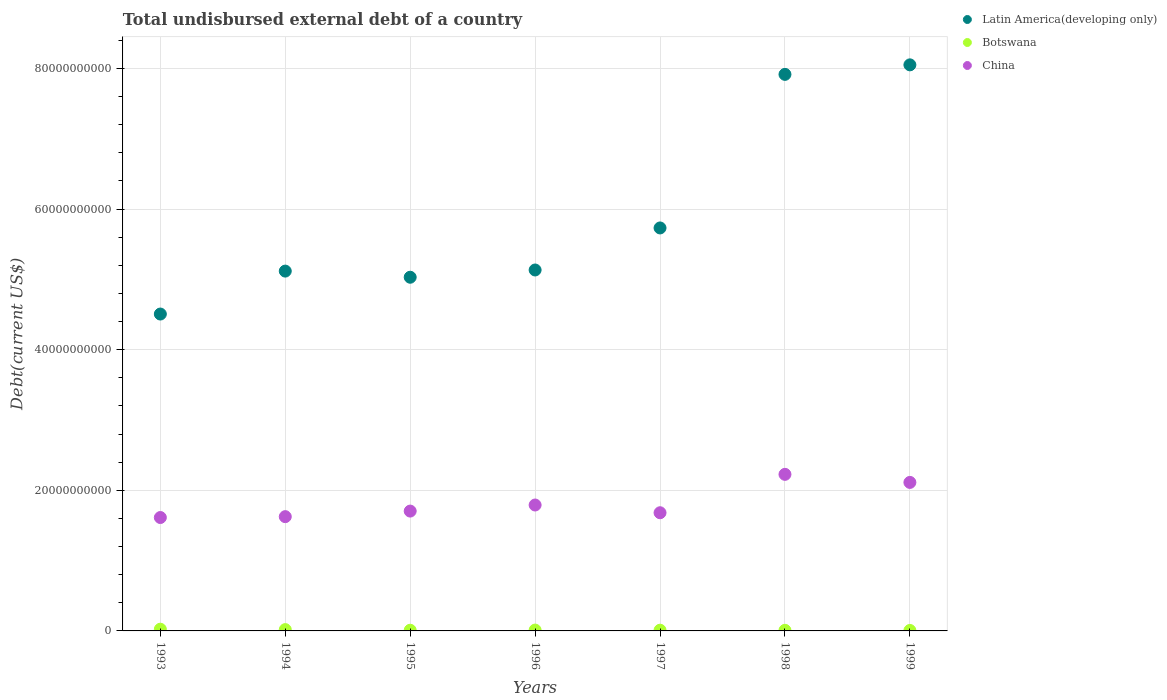How many different coloured dotlines are there?
Ensure brevity in your answer.  3. What is the total undisbursed external debt in Botswana in 1999?
Provide a short and direct response. 6.58e+07. Across all years, what is the maximum total undisbursed external debt in Botswana?
Provide a succinct answer. 2.44e+08. Across all years, what is the minimum total undisbursed external debt in China?
Offer a terse response. 1.61e+1. In which year was the total undisbursed external debt in China minimum?
Give a very brief answer. 1993. What is the total total undisbursed external debt in Latin America(developing only) in the graph?
Offer a terse response. 4.15e+11. What is the difference between the total undisbursed external debt in Botswana in 1995 and that in 1998?
Keep it short and to the point. 1.10e+07. What is the difference between the total undisbursed external debt in Botswana in 1999 and the total undisbursed external debt in Latin America(developing only) in 1996?
Offer a very short reply. -5.13e+1. What is the average total undisbursed external debt in China per year?
Give a very brief answer. 1.82e+1. In the year 1995, what is the difference between the total undisbursed external debt in China and total undisbursed external debt in Botswana?
Offer a very short reply. 1.69e+1. What is the ratio of the total undisbursed external debt in China in 1997 to that in 1998?
Your response must be concise. 0.75. Is the difference between the total undisbursed external debt in China in 1996 and 1997 greater than the difference between the total undisbursed external debt in Botswana in 1996 and 1997?
Offer a very short reply. Yes. What is the difference between the highest and the second highest total undisbursed external debt in China?
Provide a succinct answer. 1.15e+09. What is the difference between the highest and the lowest total undisbursed external debt in Latin America(developing only)?
Make the answer very short. 3.54e+1. Is the sum of the total undisbursed external debt in China in 1996 and 1998 greater than the maximum total undisbursed external debt in Botswana across all years?
Your answer should be very brief. Yes. Is it the case that in every year, the sum of the total undisbursed external debt in China and total undisbursed external debt in Latin America(developing only)  is greater than the total undisbursed external debt in Botswana?
Provide a succinct answer. Yes. Does the total undisbursed external debt in Latin America(developing only) monotonically increase over the years?
Your response must be concise. No. Is the total undisbursed external debt in Latin America(developing only) strictly less than the total undisbursed external debt in Botswana over the years?
Offer a very short reply. No. How many years are there in the graph?
Keep it short and to the point. 7. Are the values on the major ticks of Y-axis written in scientific E-notation?
Offer a terse response. No. Where does the legend appear in the graph?
Make the answer very short. Top right. How are the legend labels stacked?
Your answer should be compact. Vertical. What is the title of the graph?
Offer a terse response. Total undisbursed external debt of a country. What is the label or title of the X-axis?
Offer a terse response. Years. What is the label or title of the Y-axis?
Provide a short and direct response. Debt(current US$). What is the Debt(current US$) in Latin America(developing only) in 1993?
Keep it short and to the point. 4.51e+1. What is the Debt(current US$) of Botswana in 1993?
Your answer should be compact. 2.44e+08. What is the Debt(current US$) in China in 1993?
Your answer should be compact. 1.61e+1. What is the Debt(current US$) of Latin America(developing only) in 1994?
Make the answer very short. 5.12e+1. What is the Debt(current US$) of Botswana in 1994?
Offer a very short reply. 1.87e+08. What is the Debt(current US$) of China in 1994?
Ensure brevity in your answer.  1.63e+1. What is the Debt(current US$) of Latin America(developing only) in 1995?
Offer a very short reply. 5.03e+1. What is the Debt(current US$) in Botswana in 1995?
Keep it short and to the point. 9.74e+07. What is the Debt(current US$) in China in 1995?
Provide a short and direct response. 1.70e+1. What is the Debt(current US$) in Latin America(developing only) in 1996?
Offer a terse response. 5.13e+1. What is the Debt(current US$) of Botswana in 1996?
Offer a terse response. 1.20e+08. What is the Debt(current US$) in China in 1996?
Give a very brief answer. 1.79e+1. What is the Debt(current US$) in Latin America(developing only) in 1997?
Provide a succinct answer. 5.73e+1. What is the Debt(current US$) in Botswana in 1997?
Ensure brevity in your answer.  1.03e+08. What is the Debt(current US$) of China in 1997?
Your response must be concise. 1.68e+1. What is the Debt(current US$) of Latin America(developing only) in 1998?
Make the answer very short. 7.91e+1. What is the Debt(current US$) in Botswana in 1998?
Provide a succinct answer. 8.64e+07. What is the Debt(current US$) of China in 1998?
Your answer should be compact. 2.23e+1. What is the Debt(current US$) of Latin America(developing only) in 1999?
Give a very brief answer. 8.05e+1. What is the Debt(current US$) of Botswana in 1999?
Provide a succinct answer. 6.58e+07. What is the Debt(current US$) in China in 1999?
Keep it short and to the point. 2.11e+1. Across all years, what is the maximum Debt(current US$) in Latin America(developing only)?
Keep it short and to the point. 8.05e+1. Across all years, what is the maximum Debt(current US$) in Botswana?
Offer a very short reply. 2.44e+08. Across all years, what is the maximum Debt(current US$) of China?
Offer a very short reply. 2.23e+1. Across all years, what is the minimum Debt(current US$) of Latin America(developing only)?
Your response must be concise. 4.51e+1. Across all years, what is the minimum Debt(current US$) in Botswana?
Provide a succinct answer. 6.58e+07. Across all years, what is the minimum Debt(current US$) of China?
Give a very brief answer. 1.61e+1. What is the total Debt(current US$) in Latin America(developing only) in the graph?
Provide a short and direct response. 4.15e+11. What is the total Debt(current US$) in Botswana in the graph?
Provide a succinct answer. 9.03e+08. What is the total Debt(current US$) of China in the graph?
Your answer should be compact. 1.28e+11. What is the difference between the Debt(current US$) of Latin America(developing only) in 1993 and that in 1994?
Ensure brevity in your answer.  -6.11e+09. What is the difference between the Debt(current US$) of Botswana in 1993 and that in 1994?
Make the answer very short. 5.70e+07. What is the difference between the Debt(current US$) of China in 1993 and that in 1994?
Your response must be concise. -1.24e+08. What is the difference between the Debt(current US$) of Latin America(developing only) in 1993 and that in 1995?
Offer a very short reply. -5.23e+09. What is the difference between the Debt(current US$) of Botswana in 1993 and that in 1995?
Keep it short and to the point. 1.46e+08. What is the difference between the Debt(current US$) of China in 1993 and that in 1995?
Give a very brief answer. -9.15e+08. What is the difference between the Debt(current US$) in Latin America(developing only) in 1993 and that in 1996?
Provide a succinct answer. -6.27e+09. What is the difference between the Debt(current US$) of Botswana in 1993 and that in 1996?
Give a very brief answer. 1.23e+08. What is the difference between the Debt(current US$) in China in 1993 and that in 1996?
Your answer should be very brief. -1.78e+09. What is the difference between the Debt(current US$) in Latin America(developing only) in 1993 and that in 1997?
Offer a terse response. -1.22e+1. What is the difference between the Debt(current US$) in Botswana in 1993 and that in 1997?
Ensure brevity in your answer.  1.40e+08. What is the difference between the Debt(current US$) of China in 1993 and that in 1997?
Make the answer very short. -6.80e+08. What is the difference between the Debt(current US$) in Latin America(developing only) in 1993 and that in 1998?
Provide a short and direct response. -3.41e+1. What is the difference between the Debt(current US$) in Botswana in 1993 and that in 1998?
Make the answer very short. 1.57e+08. What is the difference between the Debt(current US$) of China in 1993 and that in 1998?
Offer a terse response. -6.14e+09. What is the difference between the Debt(current US$) in Latin America(developing only) in 1993 and that in 1999?
Your answer should be compact. -3.54e+1. What is the difference between the Debt(current US$) of Botswana in 1993 and that in 1999?
Offer a terse response. 1.78e+08. What is the difference between the Debt(current US$) in China in 1993 and that in 1999?
Your response must be concise. -4.99e+09. What is the difference between the Debt(current US$) in Latin America(developing only) in 1994 and that in 1995?
Your response must be concise. 8.73e+08. What is the difference between the Debt(current US$) in Botswana in 1994 and that in 1995?
Your answer should be compact. 8.92e+07. What is the difference between the Debt(current US$) in China in 1994 and that in 1995?
Offer a terse response. -7.91e+08. What is the difference between the Debt(current US$) in Latin America(developing only) in 1994 and that in 1996?
Offer a very short reply. -1.58e+08. What is the difference between the Debt(current US$) of Botswana in 1994 and that in 1996?
Provide a succinct answer. 6.63e+07. What is the difference between the Debt(current US$) in China in 1994 and that in 1996?
Offer a very short reply. -1.66e+09. What is the difference between the Debt(current US$) in Latin America(developing only) in 1994 and that in 1997?
Provide a short and direct response. -6.14e+09. What is the difference between the Debt(current US$) in Botswana in 1994 and that in 1997?
Give a very brief answer. 8.31e+07. What is the difference between the Debt(current US$) in China in 1994 and that in 1997?
Make the answer very short. -5.56e+08. What is the difference between the Debt(current US$) in Latin America(developing only) in 1994 and that in 1998?
Offer a terse response. -2.80e+1. What is the difference between the Debt(current US$) in Botswana in 1994 and that in 1998?
Give a very brief answer. 1.00e+08. What is the difference between the Debt(current US$) of China in 1994 and that in 1998?
Your answer should be compact. -6.02e+09. What is the difference between the Debt(current US$) of Latin America(developing only) in 1994 and that in 1999?
Your answer should be compact. -2.93e+1. What is the difference between the Debt(current US$) of Botswana in 1994 and that in 1999?
Provide a succinct answer. 1.21e+08. What is the difference between the Debt(current US$) of China in 1994 and that in 1999?
Provide a short and direct response. -4.87e+09. What is the difference between the Debt(current US$) of Latin America(developing only) in 1995 and that in 1996?
Keep it short and to the point. -1.03e+09. What is the difference between the Debt(current US$) in Botswana in 1995 and that in 1996?
Offer a very short reply. -2.28e+07. What is the difference between the Debt(current US$) in China in 1995 and that in 1996?
Keep it short and to the point. -8.65e+08. What is the difference between the Debt(current US$) in Latin America(developing only) in 1995 and that in 1997?
Your answer should be very brief. -7.01e+09. What is the difference between the Debt(current US$) in Botswana in 1995 and that in 1997?
Your response must be concise. -6.05e+06. What is the difference between the Debt(current US$) in China in 1995 and that in 1997?
Make the answer very short. 2.35e+08. What is the difference between the Debt(current US$) of Latin America(developing only) in 1995 and that in 1998?
Your response must be concise. -2.88e+1. What is the difference between the Debt(current US$) in Botswana in 1995 and that in 1998?
Keep it short and to the point. 1.10e+07. What is the difference between the Debt(current US$) in China in 1995 and that in 1998?
Ensure brevity in your answer.  -5.22e+09. What is the difference between the Debt(current US$) in Latin America(developing only) in 1995 and that in 1999?
Offer a terse response. -3.02e+1. What is the difference between the Debt(current US$) in Botswana in 1995 and that in 1999?
Ensure brevity in your answer.  3.16e+07. What is the difference between the Debt(current US$) in China in 1995 and that in 1999?
Offer a terse response. -4.08e+09. What is the difference between the Debt(current US$) in Latin America(developing only) in 1996 and that in 1997?
Ensure brevity in your answer.  -5.98e+09. What is the difference between the Debt(current US$) in Botswana in 1996 and that in 1997?
Provide a short and direct response. 1.68e+07. What is the difference between the Debt(current US$) in China in 1996 and that in 1997?
Offer a terse response. 1.10e+09. What is the difference between the Debt(current US$) in Latin America(developing only) in 1996 and that in 1998?
Offer a terse response. -2.78e+1. What is the difference between the Debt(current US$) in Botswana in 1996 and that in 1998?
Provide a succinct answer. 3.39e+07. What is the difference between the Debt(current US$) in China in 1996 and that in 1998?
Provide a succinct answer. -4.36e+09. What is the difference between the Debt(current US$) of Latin America(developing only) in 1996 and that in 1999?
Your answer should be compact. -2.92e+1. What is the difference between the Debt(current US$) in Botswana in 1996 and that in 1999?
Provide a succinct answer. 5.45e+07. What is the difference between the Debt(current US$) of China in 1996 and that in 1999?
Make the answer very short. -3.21e+09. What is the difference between the Debt(current US$) of Latin America(developing only) in 1997 and that in 1998?
Your answer should be very brief. -2.18e+1. What is the difference between the Debt(current US$) in Botswana in 1997 and that in 1998?
Make the answer very short. 1.71e+07. What is the difference between the Debt(current US$) of China in 1997 and that in 1998?
Provide a succinct answer. -5.46e+09. What is the difference between the Debt(current US$) of Latin America(developing only) in 1997 and that in 1999?
Give a very brief answer. -2.32e+1. What is the difference between the Debt(current US$) of Botswana in 1997 and that in 1999?
Make the answer very short. 3.77e+07. What is the difference between the Debt(current US$) of China in 1997 and that in 1999?
Keep it short and to the point. -4.31e+09. What is the difference between the Debt(current US$) of Latin America(developing only) in 1998 and that in 1999?
Your answer should be compact. -1.35e+09. What is the difference between the Debt(current US$) of Botswana in 1998 and that in 1999?
Offer a very short reply. 2.06e+07. What is the difference between the Debt(current US$) in China in 1998 and that in 1999?
Give a very brief answer. 1.15e+09. What is the difference between the Debt(current US$) in Latin America(developing only) in 1993 and the Debt(current US$) in Botswana in 1994?
Give a very brief answer. 4.49e+1. What is the difference between the Debt(current US$) in Latin America(developing only) in 1993 and the Debt(current US$) in China in 1994?
Provide a succinct answer. 2.88e+1. What is the difference between the Debt(current US$) in Botswana in 1993 and the Debt(current US$) in China in 1994?
Keep it short and to the point. -1.60e+1. What is the difference between the Debt(current US$) of Latin America(developing only) in 1993 and the Debt(current US$) of Botswana in 1995?
Your response must be concise. 4.50e+1. What is the difference between the Debt(current US$) of Latin America(developing only) in 1993 and the Debt(current US$) of China in 1995?
Offer a terse response. 2.80e+1. What is the difference between the Debt(current US$) in Botswana in 1993 and the Debt(current US$) in China in 1995?
Your response must be concise. -1.68e+1. What is the difference between the Debt(current US$) of Latin America(developing only) in 1993 and the Debt(current US$) of Botswana in 1996?
Keep it short and to the point. 4.49e+1. What is the difference between the Debt(current US$) in Latin America(developing only) in 1993 and the Debt(current US$) in China in 1996?
Your answer should be very brief. 2.72e+1. What is the difference between the Debt(current US$) of Botswana in 1993 and the Debt(current US$) of China in 1996?
Offer a terse response. -1.77e+1. What is the difference between the Debt(current US$) of Latin America(developing only) in 1993 and the Debt(current US$) of Botswana in 1997?
Provide a short and direct response. 4.50e+1. What is the difference between the Debt(current US$) in Latin America(developing only) in 1993 and the Debt(current US$) in China in 1997?
Give a very brief answer. 2.83e+1. What is the difference between the Debt(current US$) in Botswana in 1993 and the Debt(current US$) in China in 1997?
Your answer should be compact. -1.66e+1. What is the difference between the Debt(current US$) of Latin America(developing only) in 1993 and the Debt(current US$) of Botswana in 1998?
Offer a very short reply. 4.50e+1. What is the difference between the Debt(current US$) in Latin America(developing only) in 1993 and the Debt(current US$) in China in 1998?
Offer a terse response. 2.28e+1. What is the difference between the Debt(current US$) of Botswana in 1993 and the Debt(current US$) of China in 1998?
Your response must be concise. -2.20e+1. What is the difference between the Debt(current US$) of Latin America(developing only) in 1993 and the Debt(current US$) of Botswana in 1999?
Offer a very short reply. 4.50e+1. What is the difference between the Debt(current US$) of Latin America(developing only) in 1993 and the Debt(current US$) of China in 1999?
Provide a succinct answer. 2.39e+1. What is the difference between the Debt(current US$) of Botswana in 1993 and the Debt(current US$) of China in 1999?
Ensure brevity in your answer.  -2.09e+1. What is the difference between the Debt(current US$) in Latin America(developing only) in 1994 and the Debt(current US$) in Botswana in 1995?
Your answer should be compact. 5.11e+1. What is the difference between the Debt(current US$) in Latin America(developing only) in 1994 and the Debt(current US$) in China in 1995?
Offer a very short reply. 3.41e+1. What is the difference between the Debt(current US$) of Botswana in 1994 and the Debt(current US$) of China in 1995?
Offer a very short reply. -1.69e+1. What is the difference between the Debt(current US$) of Latin America(developing only) in 1994 and the Debt(current US$) of Botswana in 1996?
Make the answer very short. 5.10e+1. What is the difference between the Debt(current US$) of Latin America(developing only) in 1994 and the Debt(current US$) of China in 1996?
Provide a succinct answer. 3.33e+1. What is the difference between the Debt(current US$) in Botswana in 1994 and the Debt(current US$) in China in 1996?
Give a very brief answer. -1.77e+1. What is the difference between the Debt(current US$) of Latin America(developing only) in 1994 and the Debt(current US$) of Botswana in 1997?
Ensure brevity in your answer.  5.11e+1. What is the difference between the Debt(current US$) in Latin America(developing only) in 1994 and the Debt(current US$) in China in 1997?
Make the answer very short. 3.44e+1. What is the difference between the Debt(current US$) in Botswana in 1994 and the Debt(current US$) in China in 1997?
Offer a very short reply. -1.66e+1. What is the difference between the Debt(current US$) in Latin America(developing only) in 1994 and the Debt(current US$) in Botswana in 1998?
Offer a terse response. 5.11e+1. What is the difference between the Debt(current US$) in Latin America(developing only) in 1994 and the Debt(current US$) in China in 1998?
Your response must be concise. 2.89e+1. What is the difference between the Debt(current US$) in Botswana in 1994 and the Debt(current US$) in China in 1998?
Your answer should be compact. -2.21e+1. What is the difference between the Debt(current US$) in Latin America(developing only) in 1994 and the Debt(current US$) in Botswana in 1999?
Give a very brief answer. 5.11e+1. What is the difference between the Debt(current US$) in Latin America(developing only) in 1994 and the Debt(current US$) in China in 1999?
Offer a very short reply. 3.00e+1. What is the difference between the Debt(current US$) of Botswana in 1994 and the Debt(current US$) of China in 1999?
Provide a short and direct response. -2.09e+1. What is the difference between the Debt(current US$) of Latin America(developing only) in 1995 and the Debt(current US$) of Botswana in 1996?
Provide a short and direct response. 5.02e+1. What is the difference between the Debt(current US$) of Latin America(developing only) in 1995 and the Debt(current US$) of China in 1996?
Your answer should be compact. 3.24e+1. What is the difference between the Debt(current US$) in Botswana in 1995 and the Debt(current US$) in China in 1996?
Provide a succinct answer. -1.78e+1. What is the difference between the Debt(current US$) in Latin America(developing only) in 1995 and the Debt(current US$) in Botswana in 1997?
Give a very brief answer. 5.02e+1. What is the difference between the Debt(current US$) of Latin America(developing only) in 1995 and the Debt(current US$) of China in 1997?
Ensure brevity in your answer.  3.35e+1. What is the difference between the Debt(current US$) of Botswana in 1995 and the Debt(current US$) of China in 1997?
Provide a short and direct response. -1.67e+1. What is the difference between the Debt(current US$) of Latin America(developing only) in 1995 and the Debt(current US$) of Botswana in 1998?
Give a very brief answer. 5.02e+1. What is the difference between the Debt(current US$) of Latin America(developing only) in 1995 and the Debt(current US$) of China in 1998?
Your response must be concise. 2.80e+1. What is the difference between the Debt(current US$) of Botswana in 1995 and the Debt(current US$) of China in 1998?
Your answer should be compact. -2.22e+1. What is the difference between the Debt(current US$) in Latin America(developing only) in 1995 and the Debt(current US$) in Botswana in 1999?
Give a very brief answer. 5.02e+1. What is the difference between the Debt(current US$) in Latin America(developing only) in 1995 and the Debt(current US$) in China in 1999?
Ensure brevity in your answer.  2.92e+1. What is the difference between the Debt(current US$) in Botswana in 1995 and the Debt(current US$) in China in 1999?
Your answer should be very brief. -2.10e+1. What is the difference between the Debt(current US$) of Latin America(developing only) in 1996 and the Debt(current US$) of Botswana in 1997?
Your answer should be very brief. 5.12e+1. What is the difference between the Debt(current US$) in Latin America(developing only) in 1996 and the Debt(current US$) in China in 1997?
Provide a short and direct response. 3.45e+1. What is the difference between the Debt(current US$) of Botswana in 1996 and the Debt(current US$) of China in 1997?
Offer a very short reply. -1.67e+1. What is the difference between the Debt(current US$) in Latin America(developing only) in 1996 and the Debt(current US$) in Botswana in 1998?
Your answer should be very brief. 5.12e+1. What is the difference between the Debt(current US$) of Latin America(developing only) in 1996 and the Debt(current US$) of China in 1998?
Offer a very short reply. 2.91e+1. What is the difference between the Debt(current US$) in Botswana in 1996 and the Debt(current US$) in China in 1998?
Ensure brevity in your answer.  -2.21e+1. What is the difference between the Debt(current US$) in Latin America(developing only) in 1996 and the Debt(current US$) in Botswana in 1999?
Provide a short and direct response. 5.13e+1. What is the difference between the Debt(current US$) of Latin America(developing only) in 1996 and the Debt(current US$) of China in 1999?
Offer a very short reply. 3.02e+1. What is the difference between the Debt(current US$) in Botswana in 1996 and the Debt(current US$) in China in 1999?
Your response must be concise. -2.10e+1. What is the difference between the Debt(current US$) in Latin America(developing only) in 1997 and the Debt(current US$) in Botswana in 1998?
Offer a very short reply. 5.72e+1. What is the difference between the Debt(current US$) in Latin America(developing only) in 1997 and the Debt(current US$) in China in 1998?
Offer a very short reply. 3.50e+1. What is the difference between the Debt(current US$) in Botswana in 1997 and the Debt(current US$) in China in 1998?
Your answer should be very brief. -2.22e+1. What is the difference between the Debt(current US$) in Latin America(developing only) in 1997 and the Debt(current US$) in Botswana in 1999?
Make the answer very short. 5.72e+1. What is the difference between the Debt(current US$) in Latin America(developing only) in 1997 and the Debt(current US$) in China in 1999?
Ensure brevity in your answer.  3.62e+1. What is the difference between the Debt(current US$) of Botswana in 1997 and the Debt(current US$) of China in 1999?
Make the answer very short. -2.10e+1. What is the difference between the Debt(current US$) in Latin America(developing only) in 1998 and the Debt(current US$) in Botswana in 1999?
Offer a terse response. 7.91e+1. What is the difference between the Debt(current US$) of Latin America(developing only) in 1998 and the Debt(current US$) of China in 1999?
Make the answer very short. 5.80e+1. What is the difference between the Debt(current US$) in Botswana in 1998 and the Debt(current US$) in China in 1999?
Make the answer very short. -2.10e+1. What is the average Debt(current US$) of Latin America(developing only) per year?
Your answer should be compact. 5.93e+1. What is the average Debt(current US$) of Botswana per year?
Provide a short and direct response. 1.29e+08. What is the average Debt(current US$) in China per year?
Keep it short and to the point. 1.82e+1. In the year 1993, what is the difference between the Debt(current US$) in Latin America(developing only) and Debt(current US$) in Botswana?
Your answer should be compact. 4.48e+1. In the year 1993, what is the difference between the Debt(current US$) in Latin America(developing only) and Debt(current US$) in China?
Provide a short and direct response. 2.89e+1. In the year 1993, what is the difference between the Debt(current US$) in Botswana and Debt(current US$) in China?
Your answer should be compact. -1.59e+1. In the year 1994, what is the difference between the Debt(current US$) of Latin America(developing only) and Debt(current US$) of Botswana?
Provide a short and direct response. 5.10e+1. In the year 1994, what is the difference between the Debt(current US$) of Latin America(developing only) and Debt(current US$) of China?
Ensure brevity in your answer.  3.49e+1. In the year 1994, what is the difference between the Debt(current US$) of Botswana and Debt(current US$) of China?
Your answer should be very brief. -1.61e+1. In the year 1995, what is the difference between the Debt(current US$) in Latin America(developing only) and Debt(current US$) in Botswana?
Your answer should be compact. 5.02e+1. In the year 1995, what is the difference between the Debt(current US$) of Latin America(developing only) and Debt(current US$) of China?
Offer a very short reply. 3.33e+1. In the year 1995, what is the difference between the Debt(current US$) in Botswana and Debt(current US$) in China?
Offer a terse response. -1.69e+1. In the year 1996, what is the difference between the Debt(current US$) of Latin America(developing only) and Debt(current US$) of Botswana?
Your response must be concise. 5.12e+1. In the year 1996, what is the difference between the Debt(current US$) in Latin America(developing only) and Debt(current US$) in China?
Provide a short and direct response. 3.34e+1. In the year 1996, what is the difference between the Debt(current US$) of Botswana and Debt(current US$) of China?
Provide a succinct answer. -1.78e+1. In the year 1997, what is the difference between the Debt(current US$) of Latin America(developing only) and Debt(current US$) of Botswana?
Keep it short and to the point. 5.72e+1. In the year 1997, what is the difference between the Debt(current US$) in Latin America(developing only) and Debt(current US$) in China?
Offer a terse response. 4.05e+1. In the year 1997, what is the difference between the Debt(current US$) in Botswana and Debt(current US$) in China?
Your response must be concise. -1.67e+1. In the year 1998, what is the difference between the Debt(current US$) in Latin America(developing only) and Debt(current US$) in Botswana?
Ensure brevity in your answer.  7.91e+1. In the year 1998, what is the difference between the Debt(current US$) in Latin America(developing only) and Debt(current US$) in China?
Ensure brevity in your answer.  5.69e+1. In the year 1998, what is the difference between the Debt(current US$) of Botswana and Debt(current US$) of China?
Make the answer very short. -2.22e+1. In the year 1999, what is the difference between the Debt(current US$) of Latin America(developing only) and Debt(current US$) of Botswana?
Your answer should be very brief. 8.04e+1. In the year 1999, what is the difference between the Debt(current US$) of Latin America(developing only) and Debt(current US$) of China?
Keep it short and to the point. 5.94e+1. In the year 1999, what is the difference between the Debt(current US$) of Botswana and Debt(current US$) of China?
Keep it short and to the point. -2.11e+1. What is the ratio of the Debt(current US$) of Latin America(developing only) in 1993 to that in 1994?
Make the answer very short. 0.88. What is the ratio of the Debt(current US$) in Botswana in 1993 to that in 1994?
Your answer should be very brief. 1.31. What is the ratio of the Debt(current US$) of China in 1993 to that in 1994?
Your answer should be compact. 0.99. What is the ratio of the Debt(current US$) of Latin America(developing only) in 1993 to that in 1995?
Your answer should be very brief. 0.9. What is the ratio of the Debt(current US$) of Botswana in 1993 to that in 1995?
Make the answer very short. 2.5. What is the ratio of the Debt(current US$) in China in 1993 to that in 1995?
Give a very brief answer. 0.95. What is the ratio of the Debt(current US$) of Latin America(developing only) in 1993 to that in 1996?
Provide a short and direct response. 0.88. What is the ratio of the Debt(current US$) of Botswana in 1993 to that in 1996?
Keep it short and to the point. 2.03. What is the ratio of the Debt(current US$) in China in 1993 to that in 1996?
Your answer should be very brief. 0.9. What is the ratio of the Debt(current US$) in Latin America(developing only) in 1993 to that in 1997?
Your answer should be compact. 0.79. What is the ratio of the Debt(current US$) of Botswana in 1993 to that in 1997?
Make the answer very short. 2.35. What is the ratio of the Debt(current US$) of China in 1993 to that in 1997?
Your answer should be very brief. 0.96. What is the ratio of the Debt(current US$) of Latin America(developing only) in 1993 to that in 1998?
Your answer should be compact. 0.57. What is the ratio of the Debt(current US$) in Botswana in 1993 to that in 1998?
Offer a very short reply. 2.82. What is the ratio of the Debt(current US$) of China in 1993 to that in 1998?
Give a very brief answer. 0.72. What is the ratio of the Debt(current US$) of Latin America(developing only) in 1993 to that in 1999?
Your answer should be compact. 0.56. What is the ratio of the Debt(current US$) in Botswana in 1993 to that in 1999?
Your answer should be very brief. 3.7. What is the ratio of the Debt(current US$) of China in 1993 to that in 1999?
Ensure brevity in your answer.  0.76. What is the ratio of the Debt(current US$) of Latin America(developing only) in 1994 to that in 1995?
Provide a short and direct response. 1.02. What is the ratio of the Debt(current US$) of Botswana in 1994 to that in 1995?
Give a very brief answer. 1.92. What is the ratio of the Debt(current US$) in China in 1994 to that in 1995?
Make the answer very short. 0.95. What is the ratio of the Debt(current US$) in Latin America(developing only) in 1994 to that in 1996?
Your answer should be compact. 1. What is the ratio of the Debt(current US$) of Botswana in 1994 to that in 1996?
Keep it short and to the point. 1.55. What is the ratio of the Debt(current US$) in China in 1994 to that in 1996?
Provide a short and direct response. 0.91. What is the ratio of the Debt(current US$) of Latin America(developing only) in 1994 to that in 1997?
Offer a very short reply. 0.89. What is the ratio of the Debt(current US$) in Botswana in 1994 to that in 1997?
Provide a succinct answer. 1.8. What is the ratio of the Debt(current US$) of China in 1994 to that in 1997?
Keep it short and to the point. 0.97. What is the ratio of the Debt(current US$) of Latin America(developing only) in 1994 to that in 1998?
Make the answer very short. 0.65. What is the ratio of the Debt(current US$) in Botswana in 1994 to that in 1998?
Provide a succinct answer. 2.16. What is the ratio of the Debt(current US$) in China in 1994 to that in 1998?
Keep it short and to the point. 0.73. What is the ratio of the Debt(current US$) in Latin America(developing only) in 1994 to that in 1999?
Your response must be concise. 0.64. What is the ratio of the Debt(current US$) in Botswana in 1994 to that in 1999?
Your response must be concise. 2.84. What is the ratio of the Debt(current US$) of China in 1994 to that in 1999?
Your answer should be compact. 0.77. What is the ratio of the Debt(current US$) in Latin America(developing only) in 1995 to that in 1996?
Provide a short and direct response. 0.98. What is the ratio of the Debt(current US$) of Botswana in 1995 to that in 1996?
Keep it short and to the point. 0.81. What is the ratio of the Debt(current US$) in China in 1995 to that in 1996?
Keep it short and to the point. 0.95. What is the ratio of the Debt(current US$) of Latin America(developing only) in 1995 to that in 1997?
Ensure brevity in your answer.  0.88. What is the ratio of the Debt(current US$) in Botswana in 1995 to that in 1997?
Ensure brevity in your answer.  0.94. What is the ratio of the Debt(current US$) in China in 1995 to that in 1997?
Keep it short and to the point. 1.01. What is the ratio of the Debt(current US$) of Latin America(developing only) in 1995 to that in 1998?
Provide a succinct answer. 0.64. What is the ratio of the Debt(current US$) of Botswana in 1995 to that in 1998?
Ensure brevity in your answer.  1.13. What is the ratio of the Debt(current US$) in China in 1995 to that in 1998?
Your response must be concise. 0.77. What is the ratio of the Debt(current US$) in Latin America(developing only) in 1995 to that in 1999?
Keep it short and to the point. 0.62. What is the ratio of the Debt(current US$) of Botswana in 1995 to that in 1999?
Make the answer very short. 1.48. What is the ratio of the Debt(current US$) of China in 1995 to that in 1999?
Your response must be concise. 0.81. What is the ratio of the Debt(current US$) in Latin America(developing only) in 1996 to that in 1997?
Your answer should be compact. 0.9. What is the ratio of the Debt(current US$) of Botswana in 1996 to that in 1997?
Provide a succinct answer. 1.16. What is the ratio of the Debt(current US$) of China in 1996 to that in 1997?
Offer a terse response. 1.07. What is the ratio of the Debt(current US$) in Latin America(developing only) in 1996 to that in 1998?
Offer a terse response. 0.65. What is the ratio of the Debt(current US$) of Botswana in 1996 to that in 1998?
Make the answer very short. 1.39. What is the ratio of the Debt(current US$) in China in 1996 to that in 1998?
Keep it short and to the point. 0.8. What is the ratio of the Debt(current US$) in Latin America(developing only) in 1996 to that in 1999?
Make the answer very short. 0.64. What is the ratio of the Debt(current US$) of Botswana in 1996 to that in 1999?
Provide a succinct answer. 1.83. What is the ratio of the Debt(current US$) in China in 1996 to that in 1999?
Make the answer very short. 0.85. What is the ratio of the Debt(current US$) in Latin America(developing only) in 1997 to that in 1998?
Your response must be concise. 0.72. What is the ratio of the Debt(current US$) in Botswana in 1997 to that in 1998?
Give a very brief answer. 1.2. What is the ratio of the Debt(current US$) of China in 1997 to that in 1998?
Your answer should be compact. 0.75. What is the ratio of the Debt(current US$) of Latin America(developing only) in 1997 to that in 1999?
Your response must be concise. 0.71. What is the ratio of the Debt(current US$) in Botswana in 1997 to that in 1999?
Your answer should be compact. 1.57. What is the ratio of the Debt(current US$) in China in 1997 to that in 1999?
Your answer should be compact. 0.8. What is the ratio of the Debt(current US$) of Latin America(developing only) in 1998 to that in 1999?
Your answer should be compact. 0.98. What is the ratio of the Debt(current US$) in Botswana in 1998 to that in 1999?
Keep it short and to the point. 1.31. What is the ratio of the Debt(current US$) of China in 1998 to that in 1999?
Give a very brief answer. 1.05. What is the difference between the highest and the second highest Debt(current US$) of Latin America(developing only)?
Offer a terse response. 1.35e+09. What is the difference between the highest and the second highest Debt(current US$) in Botswana?
Give a very brief answer. 5.70e+07. What is the difference between the highest and the second highest Debt(current US$) in China?
Your answer should be very brief. 1.15e+09. What is the difference between the highest and the lowest Debt(current US$) of Latin America(developing only)?
Ensure brevity in your answer.  3.54e+1. What is the difference between the highest and the lowest Debt(current US$) of Botswana?
Your answer should be compact. 1.78e+08. What is the difference between the highest and the lowest Debt(current US$) in China?
Offer a very short reply. 6.14e+09. 